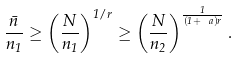<formula> <loc_0><loc_0><loc_500><loc_500>\frac { \bar { n } } { n _ { 1 } } \geq \left ( \frac { N } { n _ { 1 } } \right ) ^ { 1 / r } \geq \left ( \frac { N } { n _ { 2 } } \right ) ^ { \frac { 1 } { ( 1 + \ a ) r } } .</formula> 